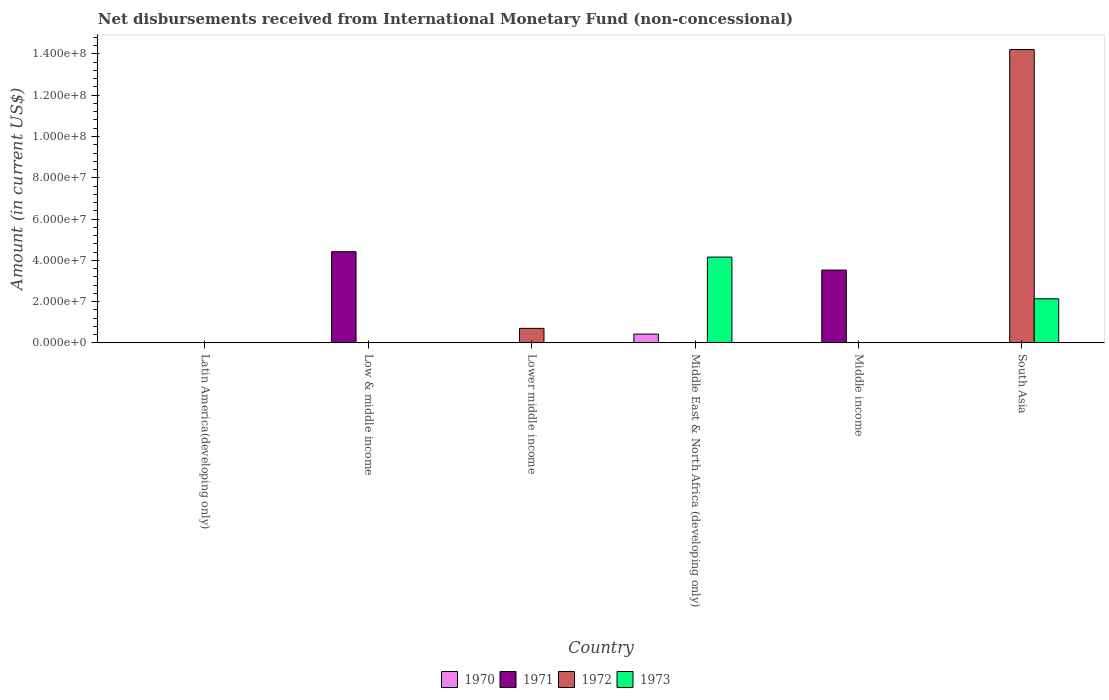How many different coloured bars are there?
Offer a terse response. 4. Are the number of bars per tick equal to the number of legend labels?
Provide a short and direct response. No. How many bars are there on the 6th tick from the left?
Provide a succinct answer. 2. What is the label of the 3rd group of bars from the left?
Give a very brief answer. Lower middle income. In how many cases, is the number of bars for a given country not equal to the number of legend labels?
Offer a terse response. 6. What is the amount of disbursements received from International Monetary Fund in 1971 in Middle income?
Your response must be concise. 3.53e+07. Across all countries, what is the maximum amount of disbursements received from International Monetary Fund in 1970?
Give a very brief answer. 4.30e+06. In which country was the amount of disbursements received from International Monetary Fund in 1970 maximum?
Your answer should be compact. Middle East & North Africa (developing only). What is the total amount of disbursements received from International Monetary Fund in 1970 in the graph?
Your response must be concise. 4.30e+06. What is the difference between the amount of disbursements received from International Monetary Fund in 1970 in Low & middle income and the amount of disbursements received from International Monetary Fund in 1973 in Middle income?
Provide a short and direct response. 0. What is the average amount of disbursements received from International Monetary Fund in 1970 per country?
Make the answer very short. 7.17e+05. In how many countries, is the amount of disbursements received from International Monetary Fund in 1971 greater than 80000000 US$?
Provide a succinct answer. 0. What is the ratio of the amount of disbursements received from International Monetary Fund in 1971 in Low & middle income to that in Middle income?
Make the answer very short. 1.25. What is the difference between the highest and the lowest amount of disbursements received from International Monetary Fund in 1972?
Keep it short and to the point. 1.42e+08. Is it the case that in every country, the sum of the amount of disbursements received from International Monetary Fund in 1971 and amount of disbursements received from International Monetary Fund in 1970 is greater than the sum of amount of disbursements received from International Monetary Fund in 1973 and amount of disbursements received from International Monetary Fund in 1972?
Provide a succinct answer. No. Is it the case that in every country, the sum of the amount of disbursements received from International Monetary Fund in 1971 and amount of disbursements received from International Monetary Fund in 1970 is greater than the amount of disbursements received from International Monetary Fund in 1972?
Your response must be concise. No. How many bars are there?
Make the answer very short. 7. How many countries are there in the graph?
Provide a succinct answer. 6. What is the difference between two consecutive major ticks on the Y-axis?
Give a very brief answer. 2.00e+07. What is the title of the graph?
Offer a terse response. Net disbursements received from International Monetary Fund (non-concessional). Does "1991" appear as one of the legend labels in the graph?
Offer a terse response. No. What is the label or title of the Y-axis?
Your answer should be compact. Amount (in current US$). What is the Amount (in current US$) of 1971 in Latin America(developing only)?
Your response must be concise. 0. What is the Amount (in current US$) in 1971 in Low & middle income?
Make the answer very short. 4.42e+07. What is the Amount (in current US$) in 1971 in Lower middle income?
Keep it short and to the point. 0. What is the Amount (in current US$) in 1972 in Lower middle income?
Make the answer very short. 7.06e+06. What is the Amount (in current US$) in 1973 in Lower middle income?
Offer a very short reply. 0. What is the Amount (in current US$) in 1970 in Middle East & North Africa (developing only)?
Your response must be concise. 4.30e+06. What is the Amount (in current US$) in 1973 in Middle East & North Africa (developing only)?
Offer a very short reply. 4.16e+07. What is the Amount (in current US$) in 1970 in Middle income?
Keep it short and to the point. 0. What is the Amount (in current US$) of 1971 in Middle income?
Provide a succinct answer. 3.53e+07. What is the Amount (in current US$) of 1970 in South Asia?
Offer a very short reply. 0. What is the Amount (in current US$) in 1971 in South Asia?
Provide a short and direct response. 0. What is the Amount (in current US$) of 1972 in South Asia?
Provide a short and direct response. 1.42e+08. What is the Amount (in current US$) of 1973 in South Asia?
Your answer should be very brief. 2.14e+07. Across all countries, what is the maximum Amount (in current US$) of 1970?
Ensure brevity in your answer.  4.30e+06. Across all countries, what is the maximum Amount (in current US$) of 1971?
Offer a very short reply. 4.42e+07. Across all countries, what is the maximum Amount (in current US$) of 1972?
Offer a very short reply. 1.42e+08. Across all countries, what is the maximum Amount (in current US$) of 1973?
Your response must be concise. 4.16e+07. What is the total Amount (in current US$) in 1970 in the graph?
Keep it short and to the point. 4.30e+06. What is the total Amount (in current US$) of 1971 in the graph?
Give a very brief answer. 7.95e+07. What is the total Amount (in current US$) of 1972 in the graph?
Offer a very short reply. 1.49e+08. What is the total Amount (in current US$) of 1973 in the graph?
Give a very brief answer. 6.30e+07. What is the difference between the Amount (in current US$) in 1971 in Low & middle income and that in Middle income?
Your response must be concise. 8.88e+06. What is the difference between the Amount (in current US$) of 1972 in Lower middle income and that in South Asia?
Your answer should be compact. -1.35e+08. What is the difference between the Amount (in current US$) of 1973 in Middle East & North Africa (developing only) and that in South Asia?
Offer a terse response. 2.02e+07. What is the difference between the Amount (in current US$) of 1971 in Low & middle income and the Amount (in current US$) of 1972 in Lower middle income?
Your response must be concise. 3.71e+07. What is the difference between the Amount (in current US$) of 1971 in Low & middle income and the Amount (in current US$) of 1973 in Middle East & North Africa (developing only)?
Offer a terse response. 2.60e+06. What is the difference between the Amount (in current US$) in 1971 in Low & middle income and the Amount (in current US$) in 1972 in South Asia?
Offer a very short reply. -9.79e+07. What is the difference between the Amount (in current US$) of 1971 in Low & middle income and the Amount (in current US$) of 1973 in South Asia?
Your response must be concise. 2.28e+07. What is the difference between the Amount (in current US$) in 1972 in Lower middle income and the Amount (in current US$) in 1973 in Middle East & North Africa (developing only)?
Give a very brief answer. -3.45e+07. What is the difference between the Amount (in current US$) in 1972 in Lower middle income and the Amount (in current US$) in 1973 in South Asia?
Provide a succinct answer. -1.43e+07. What is the difference between the Amount (in current US$) of 1970 in Middle East & North Africa (developing only) and the Amount (in current US$) of 1971 in Middle income?
Provide a succinct answer. -3.10e+07. What is the difference between the Amount (in current US$) in 1970 in Middle East & North Africa (developing only) and the Amount (in current US$) in 1972 in South Asia?
Offer a terse response. -1.38e+08. What is the difference between the Amount (in current US$) of 1970 in Middle East & North Africa (developing only) and the Amount (in current US$) of 1973 in South Asia?
Keep it short and to the point. -1.71e+07. What is the difference between the Amount (in current US$) of 1971 in Middle income and the Amount (in current US$) of 1972 in South Asia?
Give a very brief answer. -1.07e+08. What is the difference between the Amount (in current US$) in 1971 in Middle income and the Amount (in current US$) in 1973 in South Asia?
Provide a succinct answer. 1.39e+07. What is the average Amount (in current US$) of 1970 per country?
Your answer should be compact. 7.17e+05. What is the average Amount (in current US$) of 1971 per country?
Keep it short and to the point. 1.32e+07. What is the average Amount (in current US$) of 1972 per country?
Provide a succinct answer. 2.49e+07. What is the average Amount (in current US$) in 1973 per country?
Ensure brevity in your answer.  1.05e+07. What is the difference between the Amount (in current US$) of 1970 and Amount (in current US$) of 1973 in Middle East & North Africa (developing only)?
Your answer should be very brief. -3.73e+07. What is the difference between the Amount (in current US$) in 1972 and Amount (in current US$) in 1973 in South Asia?
Make the answer very short. 1.21e+08. What is the ratio of the Amount (in current US$) in 1971 in Low & middle income to that in Middle income?
Offer a terse response. 1.25. What is the ratio of the Amount (in current US$) in 1972 in Lower middle income to that in South Asia?
Offer a very short reply. 0.05. What is the ratio of the Amount (in current US$) in 1973 in Middle East & North Africa (developing only) to that in South Asia?
Your answer should be very brief. 1.94. What is the difference between the highest and the lowest Amount (in current US$) in 1970?
Your answer should be compact. 4.30e+06. What is the difference between the highest and the lowest Amount (in current US$) of 1971?
Keep it short and to the point. 4.42e+07. What is the difference between the highest and the lowest Amount (in current US$) in 1972?
Provide a short and direct response. 1.42e+08. What is the difference between the highest and the lowest Amount (in current US$) in 1973?
Make the answer very short. 4.16e+07. 